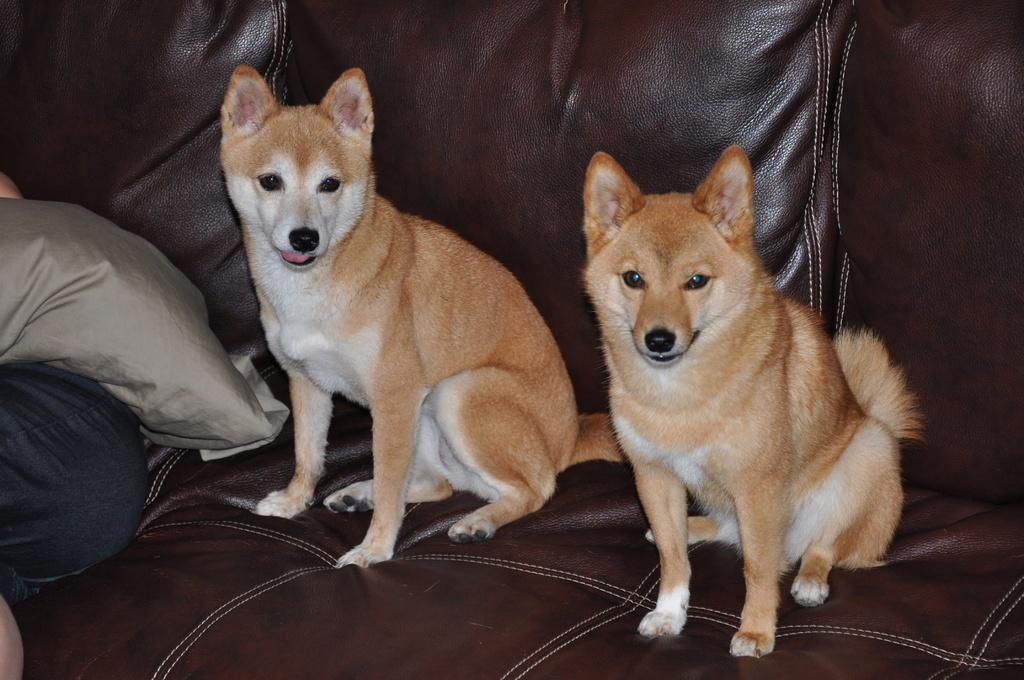What is the number of animals present in the image? There are two animals in the image. Where are the animals located in the image? The animals are on a couch. What else can be seen on the couch besides the animals? There is a cushion visible in the image. Can you describe the position of the cushion in the image? The cushion is on a person's leg. What type of song is the pancake playing in the image? There is no pancake or song present in the image. 